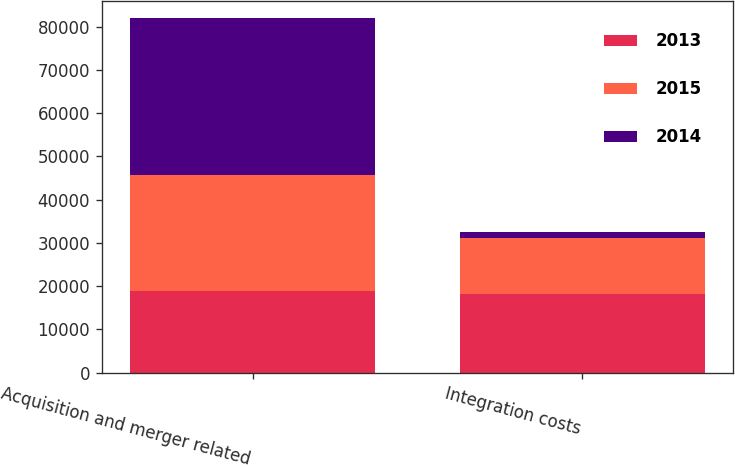Convert chart to OTSL. <chart><loc_0><loc_0><loc_500><loc_500><stacked_bar_chart><ecel><fcel>Acquisition and merger related<fcel>Integration costs<nl><fcel>2013<fcel>18799<fcel>18097<nl><fcel>2015<fcel>26969<fcel>13057<nl><fcel>2014<fcel>36172<fcel>1424<nl></chart> 